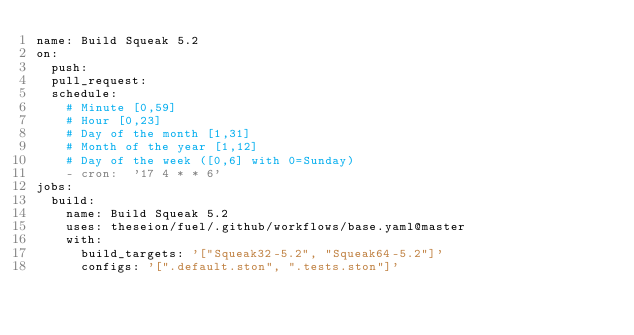Convert code to text. <code><loc_0><loc_0><loc_500><loc_500><_YAML_>name: Build Squeak 5.2
on:
  push:
  pull_request:
  schedule:
    # Minute [0,59]
    # Hour [0,23]
    # Day of the month [1,31]
    # Month of the year [1,12]
    # Day of the week ([0,6] with 0=Sunday)
    - cron:  '17 4 * * 6'
jobs:
  build:
    name: Build Squeak 5.2
    uses: theseion/fuel/.github/workflows/base.yaml@master
    with:
      build_targets: '["Squeak32-5.2", "Squeak64-5.2"]'
      configs: '[".default.ston", ".tests.ston"]'</code> 